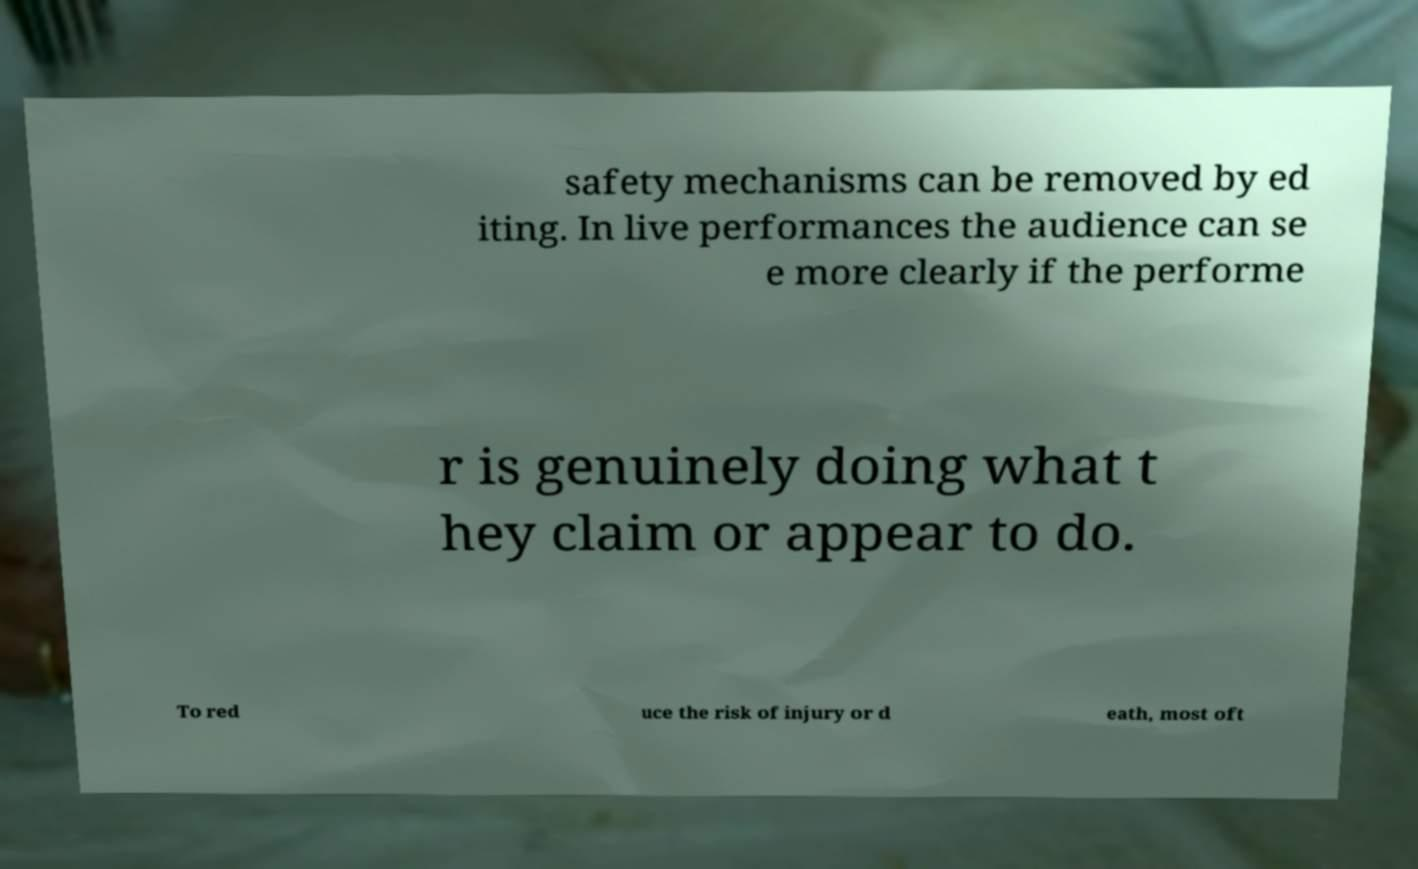Could you extract and type out the text from this image? safety mechanisms can be removed by ed iting. In live performances the audience can se e more clearly if the performe r is genuinely doing what t hey claim or appear to do. To red uce the risk of injury or d eath, most oft 